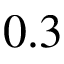Convert formula to latex. <formula><loc_0><loc_0><loc_500><loc_500>0 . 3</formula> 